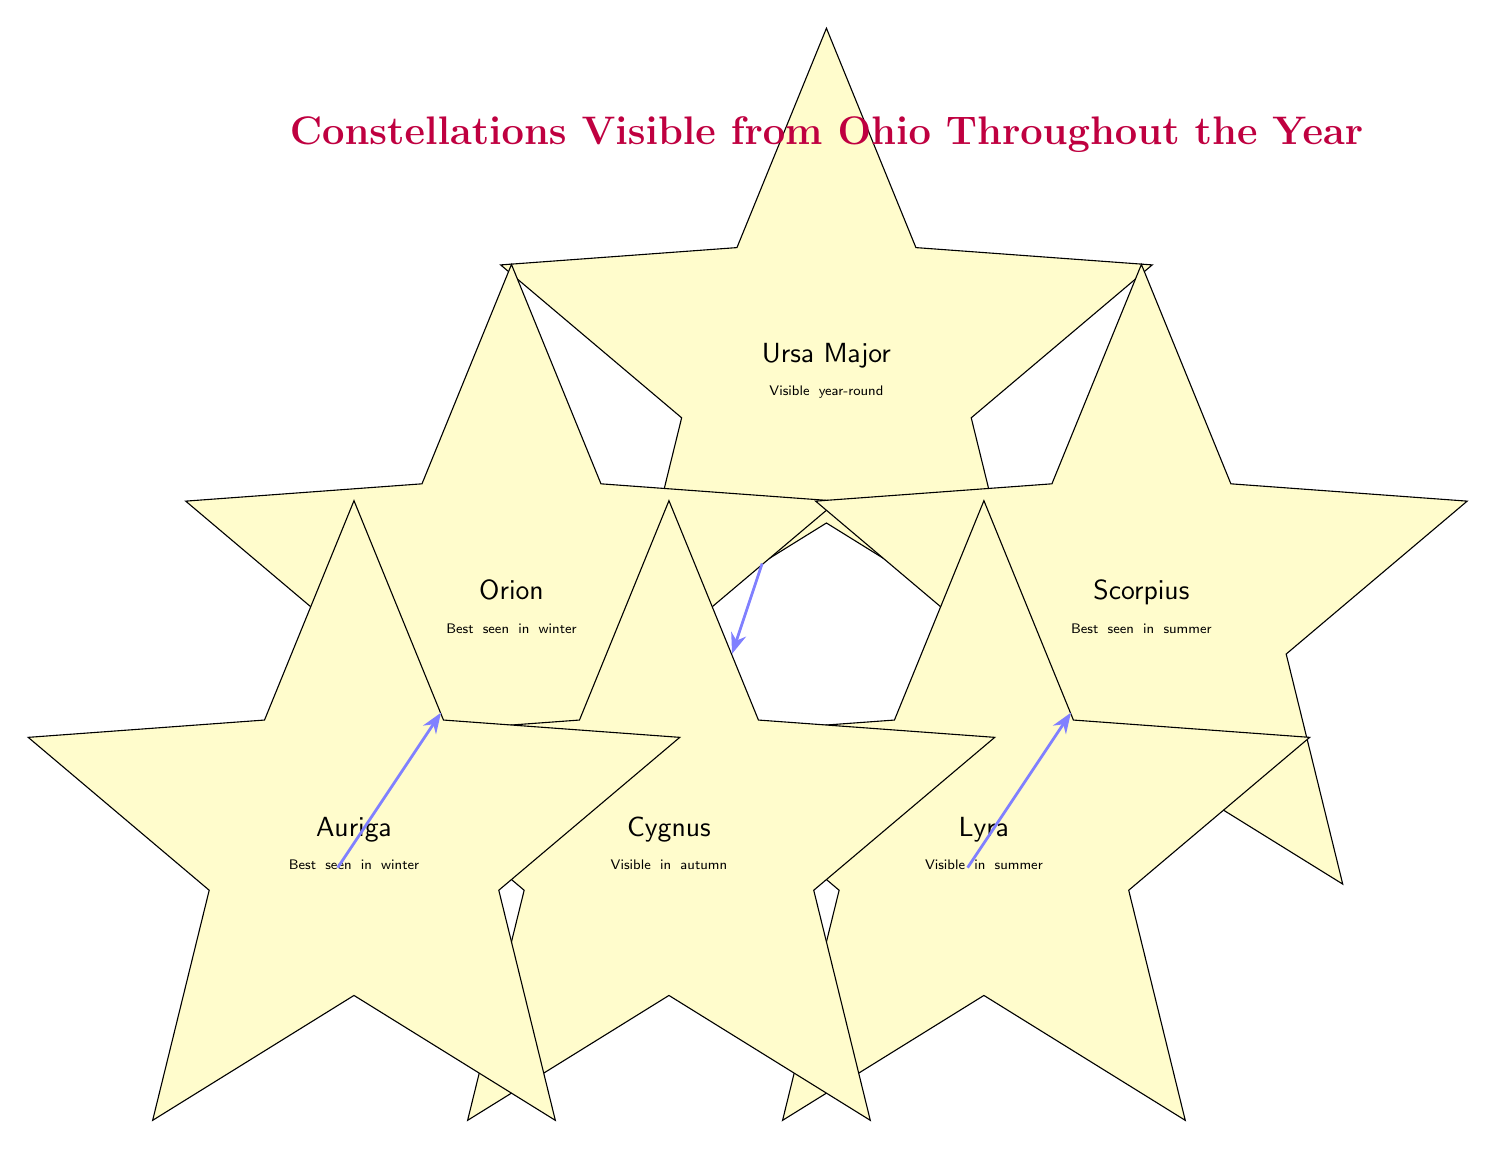What are the names of the constellations visible year-round from Ohio? The diagram indicates that Ursa Major is the constellation visible year-round from Ohio, as denoted by the text inside its corresponding node.
Answer: Ursa Major How many constellations are best seen in winter? Observing the diagram, there are two nodes labeled with "Best seen in winter," which are Orion and Auriga, thus making a count of two.
Answer: 2 What type of constellations does the edge between Orion and Auriga represent? The edge connecting Orion and Auriga has a label saying "Winter constellations," which classifies the relationship between these two nodes accordingly.
Answer: Winter constellations Which constellation is best seen in summer? The diagram shows a specific node labeled Scorpius and indicates it with a note stating "Best seen in summer," directly answering the question.
Answer: Scorpius Which constellation is visible in autumn according to the diagram? According to the visual information presented in the diagram, the node labeled Cygnus also includes the phrase "Visible in autumn," making it the answer to this question.
Answer: Cygnus How many constellations are shown in this diagram? The diagram includes a total of six nodes representing different constellations, thus the count of nodes gives the answer to this question.
Answer: 6 What seasonal classification do Lyra and Scorpius share? The diagram indicates that both Lyra and Scorpius are grouped under the label "Summer constellations," which connects both nodes indicating a shared classification.
Answer: Summer constellations Which constellation connects year-round constellations with autumn constellations? The connection observed in the edge labeled "Year-round and Autumn constellations" leads from Ursa Major to Cygnus, indicating that Ursa Major relates them both.
Answer: Ursa Major 